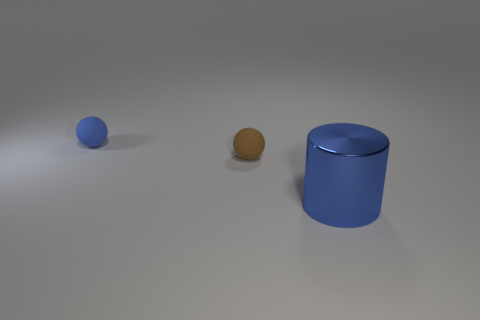There is a object that is both in front of the blue sphere and on the left side of the blue metallic thing; what shape is it?
Give a very brief answer. Sphere. How many purple shiny objects are the same shape as the brown thing?
Provide a short and direct response. 0. What size is the brown object that is made of the same material as the tiny blue sphere?
Your answer should be compact. Small. What number of rubber objects have the same size as the brown ball?
Keep it short and to the point. 1. There is a thing that is the same color as the large metal cylinder; what is its size?
Keep it short and to the point. Small. There is a sphere that is behind the small ball that is to the right of the blue rubber thing; what is its color?
Your answer should be compact. Blue. Are there any tiny matte spheres that have the same color as the big cylinder?
Your answer should be compact. Yes. The other sphere that is the same size as the blue matte ball is what color?
Offer a very short reply. Brown. Does the blue object left of the big cylinder have the same material as the large blue object?
Your answer should be very brief. No. Is there a rubber ball that is in front of the matte ball right of the small rubber ball behind the tiny brown rubber thing?
Provide a short and direct response. No. 